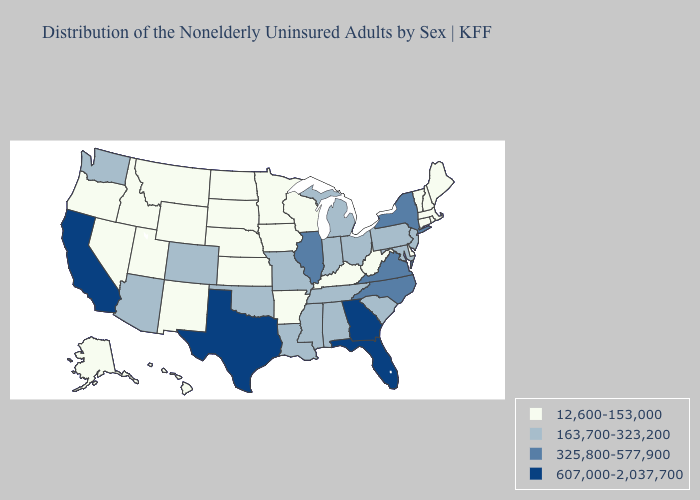Among the states that border Idaho , does Washington have the lowest value?
Give a very brief answer. No. Does Maine have the highest value in the USA?
Give a very brief answer. No. What is the lowest value in the USA?
Keep it brief. 12,600-153,000. Which states have the lowest value in the USA?
Quick response, please. Alaska, Arkansas, Connecticut, Delaware, Hawaii, Idaho, Iowa, Kansas, Kentucky, Maine, Massachusetts, Minnesota, Montana, Nebraska, Nevada, New Hampshire, New Mexico, North Dakota, Oregon, Rhode Island, South Dakota, Utah, Vermont, West Virginia, Wisconsin, Wyoming. What is the lowest value in the USA?
Keep it brief. 12,600-153,000. What is the highest value in the USA?
Write a very short answer. 607,000-2,037,700. How many symbols are there in the legend?
Answer briefly. 4. Which states hav the highest value in the South?
Quick response, please. Florida, Georgia, Texas. Does Illinois have a lower value than Texas?
Short answer required. Yes. What is the value of Maine?
Quick response, please. 12,600-153,000. What is the value of Massachusetts?
Keep it brief. 12,600-153,000. Does Michigan have the same value as North Carolina?
Concise answer only. No. Does Florida have a higher value than Arizona?
Write a very short answer. Yes. Is the legend a continuous bar?
Answer briefly. No. 